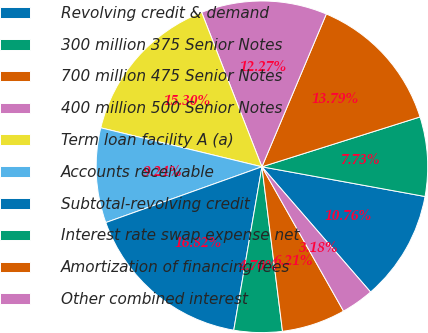Convert chart to OTSL. <chart><loc_0><loc_0><loc_500><loc_500><pie_chart><fcel>Revolving credit & demand<fcel>300 million 375 Senior Notes<fcel>700 million 475 Senior Notes<fcel>400 million 500 Senior Notes<fcel>Term loan facility A (a)<fcel>Accounts receivable<fcel>Subtotal-revolving credit<fcel>Interest rate swap expense net<fcel>Amortization of financing fees<fcel>Other combined interest<nl><fcel>10.76%<fcel>7.73%<fcel>13.79%<fcel>12.27%<fcel>15.3%<fcel>9.24%<fcel>16.82%<fcel>4.7%<fcel>6.21%<fcel>3.18%<nl></chart> 